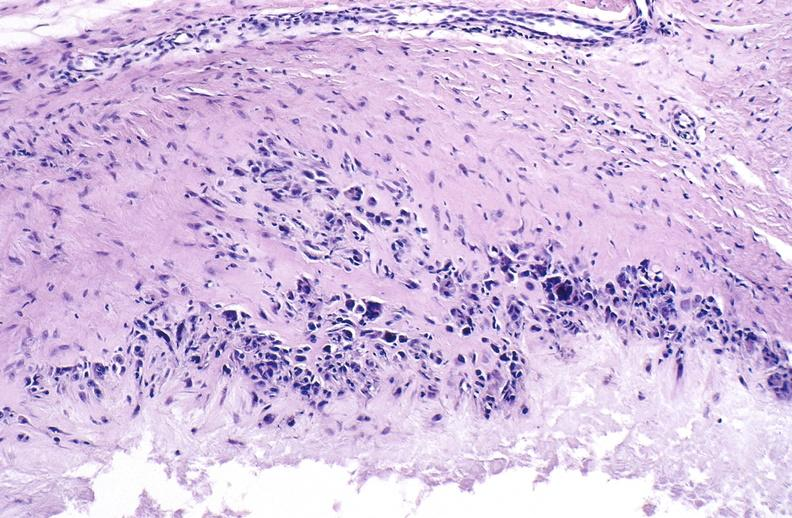what is present?
Answer the question using a single word or phrase. Joints 